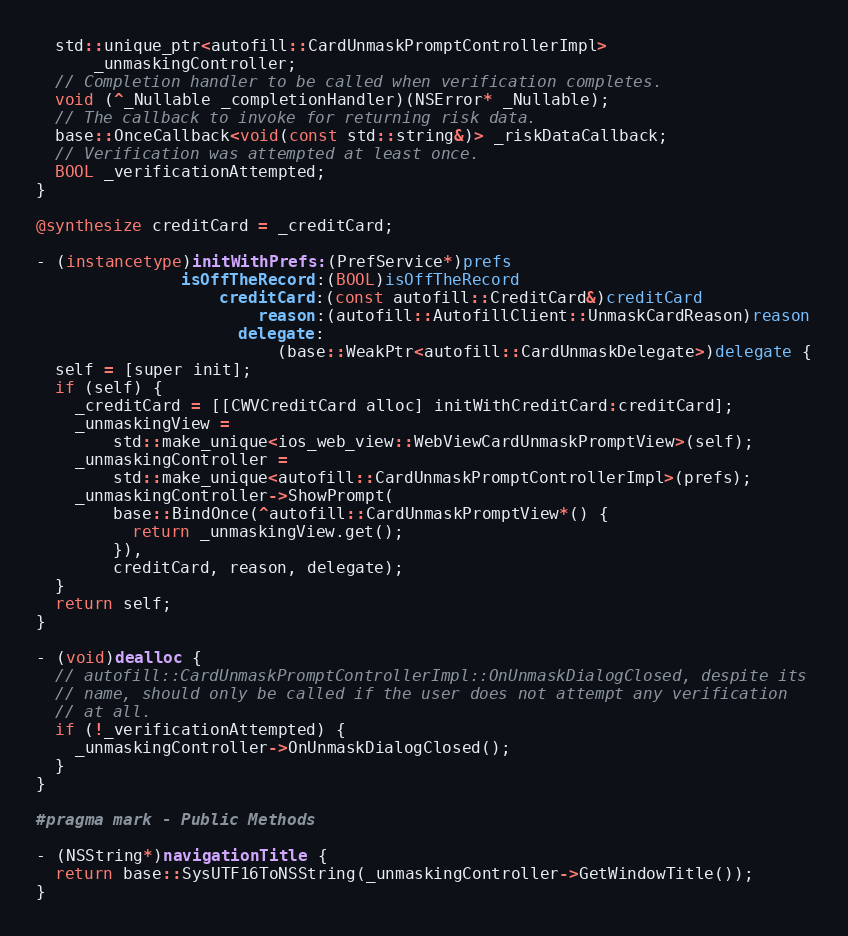Convert code to text. <code><loc_0><loc_0><loc_500><loc_500><_ObjectiveC_>  std::unique_ptr<autofill::CardUnmaskPromptControllerImpl>
      _unmaskingController;
  // Completion handler to be called when verification completes.
  void (^_Nullable _completionHandler)(NSError* _Nullable);
  // The callback to invoke for returning risk data.
  base::OnceCallback<void(const std::string&)> _riskDataCallback;
  // Verification was attempted at least once.
  BOOL _verificationAttempted;
}

@synthesize creditCard = _creditCard;

- (instancetype)initWithPrefs:(PrefService*)prefs
               isOffTheRecord:(BOOL)isOffTheRecord
                   creditCard:(const autofill::CreditCard&)creditCard
                       reason:(autofill::AutofillClient::UnmaskCardReason)reason
                     delegate:
                         (base::WeakPtr<autofill::CardUnmaskDelegate>)delegate {
  self = [super init];
  if (self) {
    _creditCard = [[CWVCreditCard alloc] initWithCreditCard:creditCard];
    _unmaskingView =
        std::make_unique<ios_web_view::WebViewCardUnmaskPromptView>(self);
    _unmaskingController =
        std::make_unique<autofill::CardUnmaskPromptControllerImpl>(prefs);
    _unmaskingController->ShowPrompt(
        base::BindOnce(^autofill::CardUnmaskPromptView*() {
          return _unmaskingView.get();
        }),
        creditCard, reason, delegate);
  }
  return self;
}

- (void)dealloc {
  // autofill::CardUnmaskPromptControllerImpl::OnUnmaskDialogClosed, despite its
  // name, should only be called if the user does not attempt any verification
  // at all.
  if (!_verificationAttempted) {
    _unmaskingController->OnUnmaskDialogClosed();
  }
}

#pragma mark - Public Methods

- (NSString*)navigationTitle {
  return base::SysUTF16ToNSString(_unmaskingController->GetWindowTitle());
}
</code> 